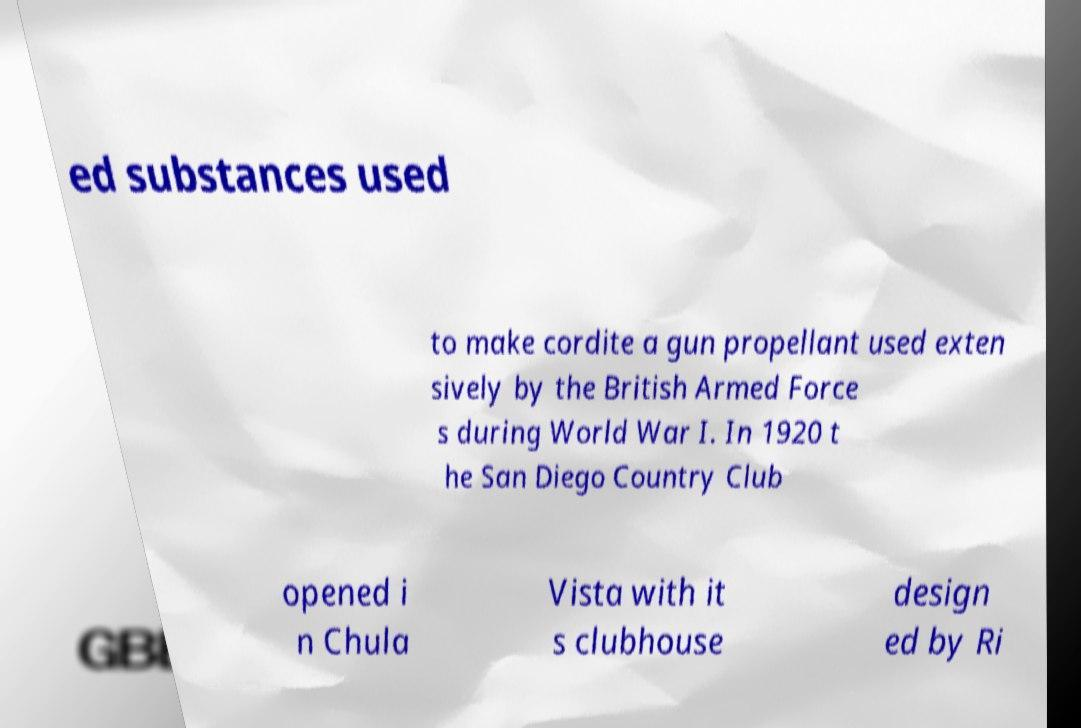Please identify and transcribe the text found in this image. ed substances used to make cordite a gun propellant used exten sively by the British Armed Force s during World War I. In 1920 t he San Diego Country Club opened i n Chula Vista with it s clubhouse design ed by Ri 